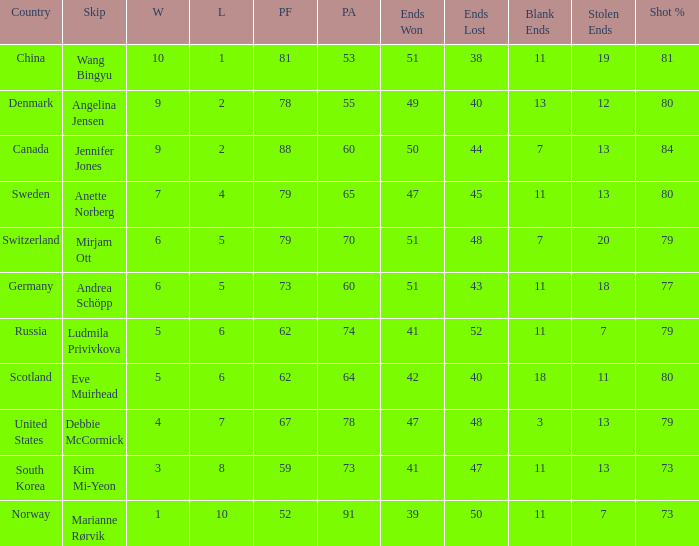When the country was Scotland, how many ends were won? 1.0. 